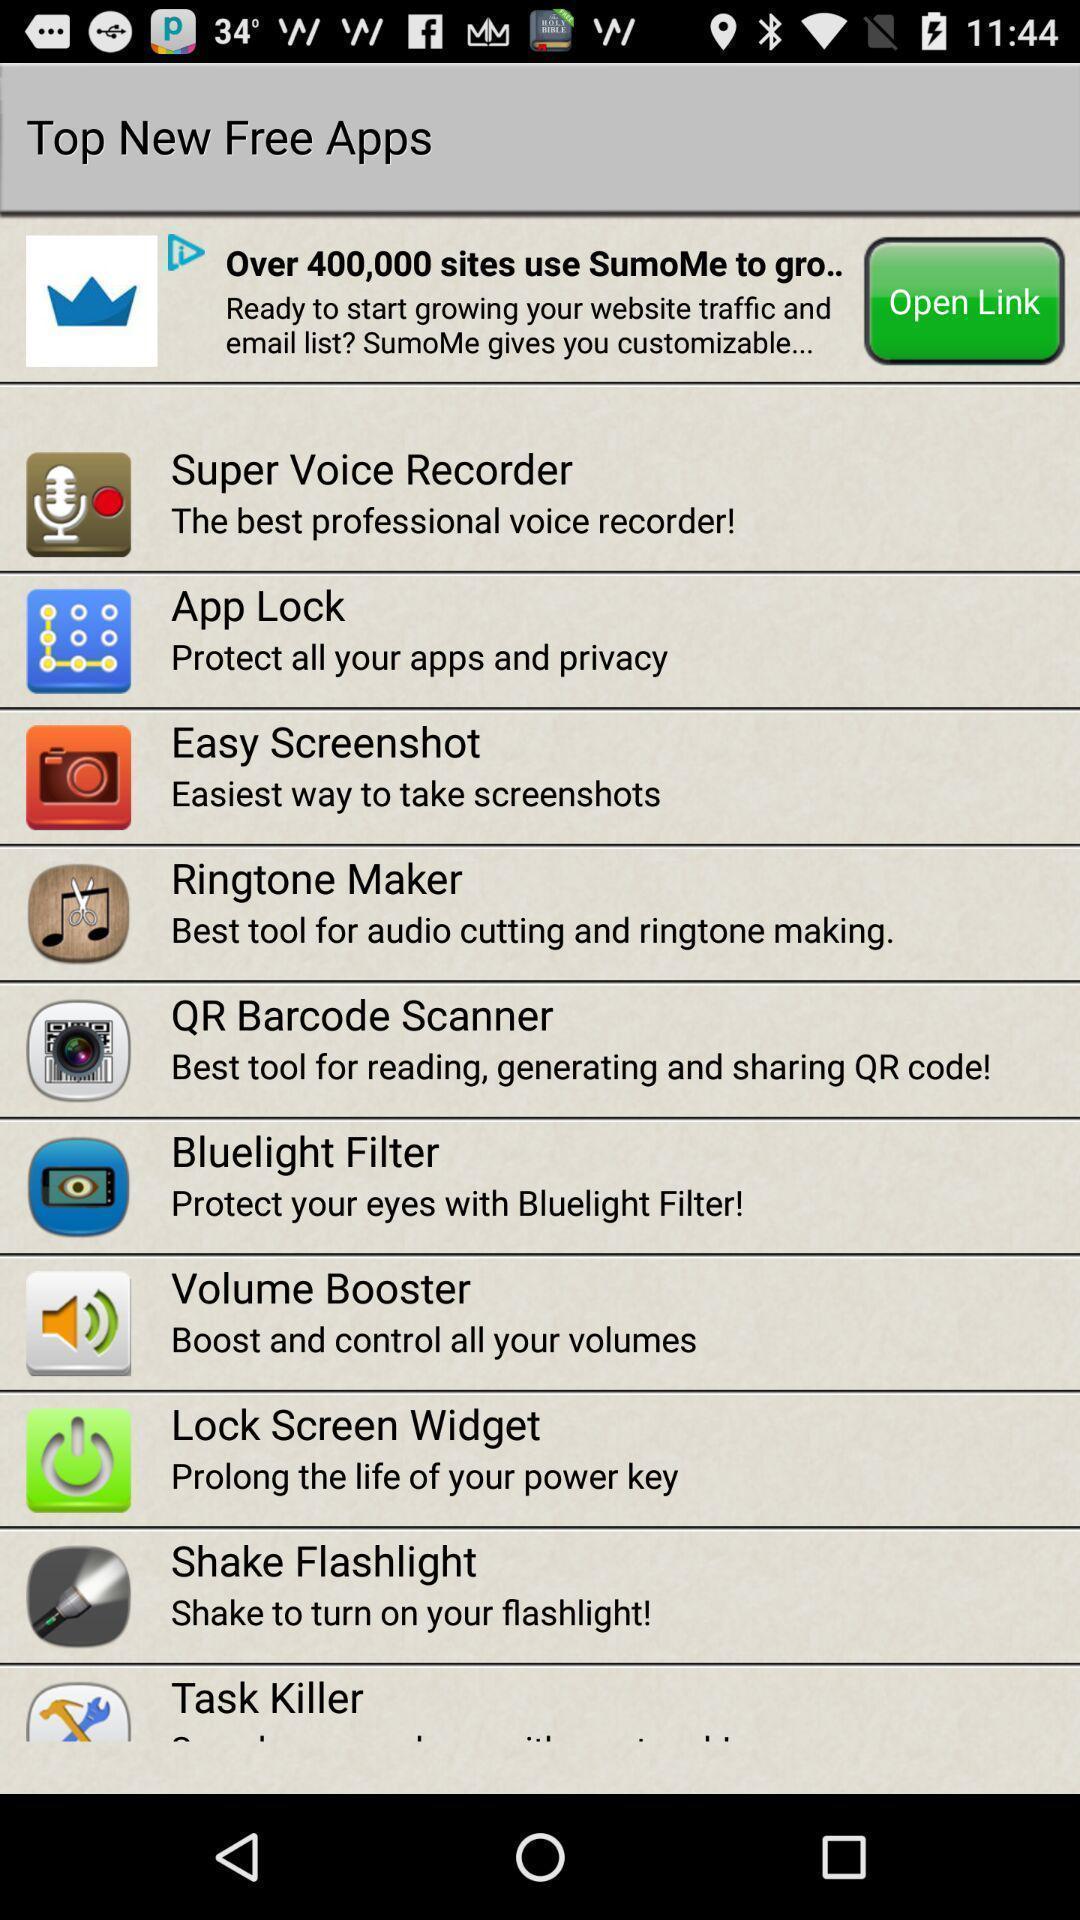Describe the visual elements of this screenshot. Page displaying various free apps. 